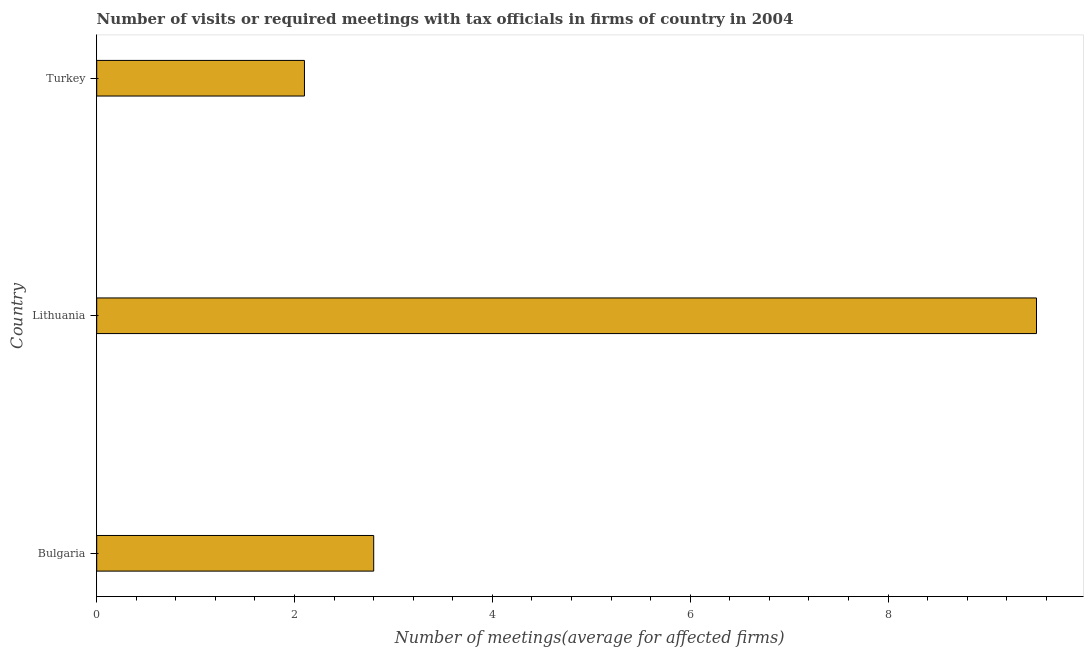What is the title of the graph?
Give a very brief answer. Number of visits or required meetings with tax officials in firms of country in 2004. What is the label or title of the X-axis?
Offer a terse response. Number of meetings(average for affected firms). What is the number of required meetings with tax officials in Lithuania?
Ensure brevity in your answer.  9.5. In which country was the number of required meetings with tax officials maximum?
Keep it short and to the point. Lithuania. In which country was the number of required meetings with tax officials minimum?
Provide a short and direct response. Turkey. What is the difference between the number of required meetings with tax officials in Lithuania and Turkey?
Your answer should be very brief. 7.4. In how many countries, is the number of required meetings with tax officials greater than 8.4 ?
Offer a very short reply. 1. What is the ratio of the number of required meetings with tax officials in Lithuania to that in Turkey?
Keep it short and to the point. 4.52. Is the number of required meetings with tax officials in Bulgaria less than that in Lithuania?
Provide a succinct answer. Yes. Is the sum of the number of required meetings with tax officials in Bulgaria and Lithuania greater than the maximum number of required meetings with tax officials across all countries?
Your answer should be compact. Yes. How many countries are there in the graph?
Provide a short and direct response. 3. What is the Number of meetings(average for affected firms) of Turkey?
Your answer should be compact. 2.1. What is the difference between the Number of meetings(average for affected firms) in Bulgaria and Lithuania?
Offer a very short reply. -6.7. What is the difference between the Number of meetings(average for affected firms) in Lithuania and Turkey?
Give a very brief answer. 7.4. What is the ratio of the Number of meetings(average for affected firms) in Bulgaria to that in Lithuania?
Provide a succinct answer. 0.29. What is the ratio of the Number of meetings(average for affected firms) in Bulgaria to that in Turkey?
Your answer should be compact. 1.33. What is the ratio of the Number of meetings(average for affected firms) in Lithuania to that in Turkey?
Keep it short and to the point. 4.52. 